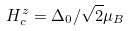Convert formula to latex. <formula><loc_0><loc_0><loc_500><loc_500>H _ { c } ^ { z } = \Delta _ { 0 } / \sqrt { 2 } \mu _ { B }</formula> 